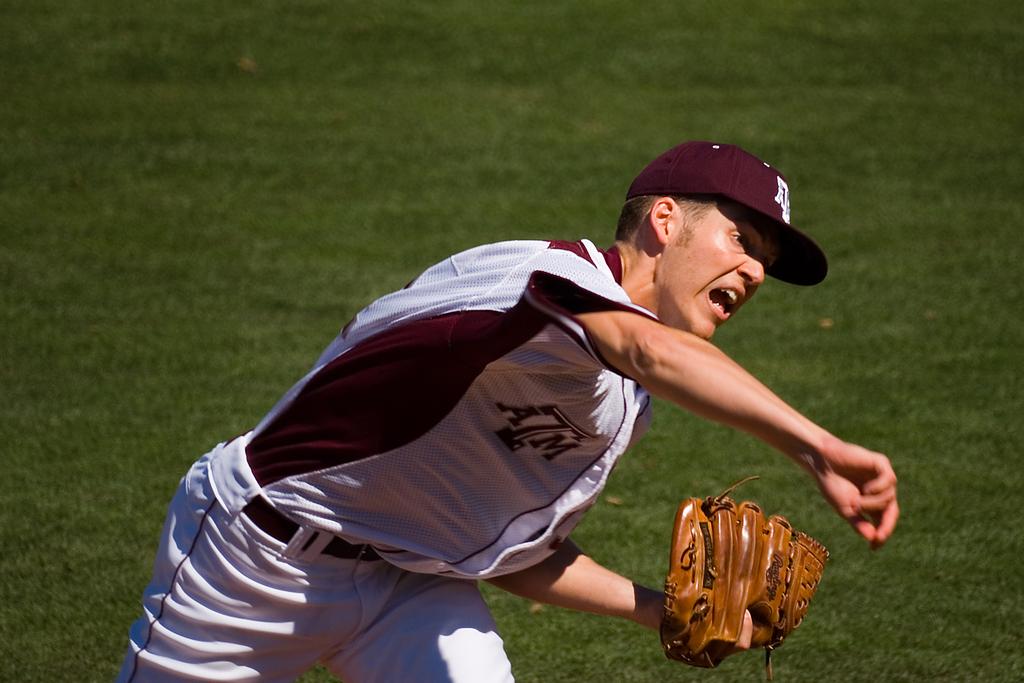What college does he play for?
Provide a succinct answer. Atm. What does the jersey say over the player's right breast?
Keep it short and to the point. Atm. 